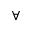<formula> <loc_0><loc_0><loc_500><loc_500>\forall</formula> 